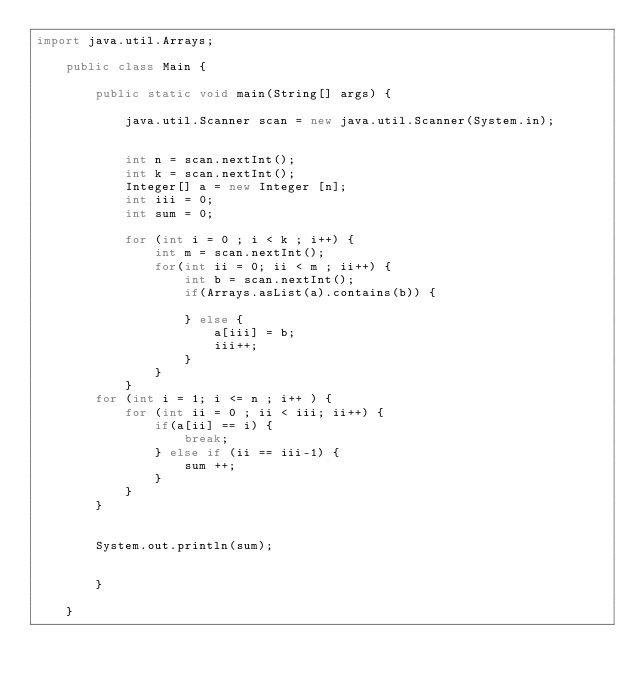<code> <loc_0><loc_0><loc_500><loc_500><_Java_>import java.util.Arrays;

	public class Main {
		 
		public static void main(String[] args) {
	 
			java.util.Scanner scan = new java.util.Scanner(System.in);
		

			int n = scan.nextInt();
			int k = scan.nextInt();
			Integer[] a = new Integer [n];
			int iii = 0;
			int sum = 0;
			
			for (int i = 0 ; i < k ; i++) {
				int m = scan.nextInt();
				for(int ii = 0; ii < m ; ii++) {
					int b = scan.nextInt();
					if(Arrays.asList(a).contains(b)) {
						
					} else {
						a[iii] = b;
						iii++;
					}
				}
			}
		for (int i = 1; i <= n ; i++ ) {
			for (int ii = 0 ; ii < iii; ii++) {
				if(a[ii] == i) {
					break;
				} else if (ii == iii-1) {
					sum ++;
				}
			}
		}
		
		
		System.out.println(sum);
		
		
		}
	 
	}
</code> 